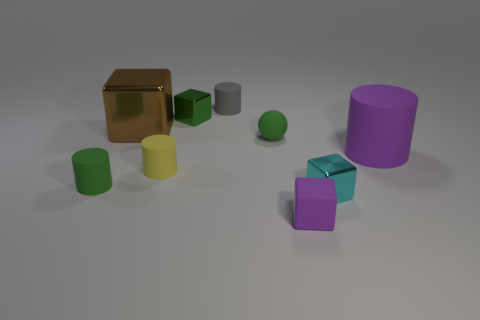What materials do the objects in the image appear to be made of? The objects in the image seem to be made of various materials. The cube is highly reflective and has a golden hue, suggesting a metallic look. The cylinders and spheres appear matte, possibly indicating a plastic or rubber composition. 